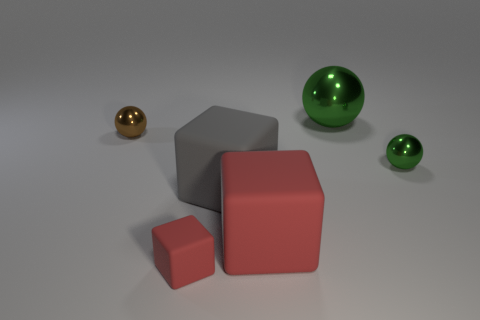Is the number of large red things that are behind the large gray block less than the number of large gray objects that are in front of the big red rubber cube?
Keep it short and to the point. No. There is a small sphere in front of the small metallic ball that is behind the green shiny sphere in front of the large green metal object; what is its material?
Provide a short and direct response. Metal. There is a thing that is both to the right of the tiny red matte cube and to the left of the big red matte cube; how big is it?
Provide a short and direct response. Large. What number of blocks are either small rubber objects or brown objects?
Make the answer very short. 1. There is a rubber cube that is the same size as the gray thing; what is its color?
Offer a terse response. Red. Are there any other things that have the same shape as the small matte object?
Your response must be concise. Yes. The other big matte thing that is the same shape as the gray rubber object is what color?
Your answer should be very brief. Red. How many objects are either tiny matte objects or tiny red blocks that are to the left of the big sphere?
Offer a very short reply. 1. Is the number of red matte things in front of the big metallic ball less than the number of big red rubber objects?
Keep it short and to the point. No. There is a sphere that is in front of the brown shiny object on the left side of the green object that is in front of the brown thing; what is its size?
Your answer should be very brief. Small. 